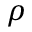<formula> <loc_0><loc_0><loc_500><loc_500>\rho</formula> 